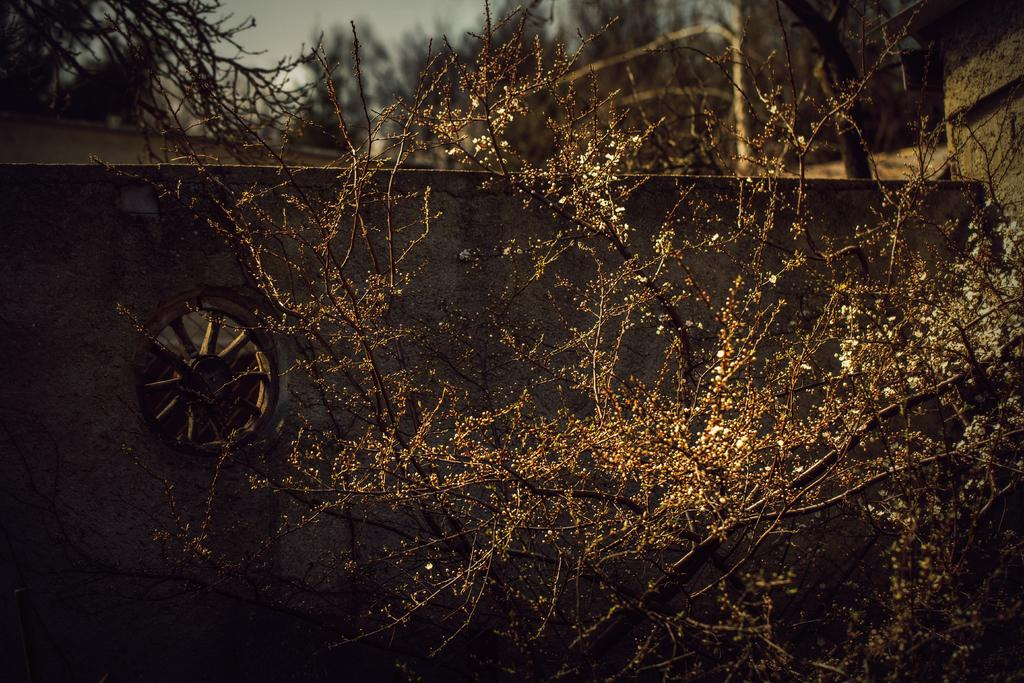What type of vegetation can be seen in the image? There are trees in the image. Where is the tyre located in the image? The tyre is on the left side of the image. What can be seen in the background of the image? There are trees in the background of the image. What is visible at the top of the image? The sky is visible at the top of the image. How many minutes does it take for the vegetable to grow in the image? There is no vegetable present in the image, so it is not possible to determine how long it would take to grow. 